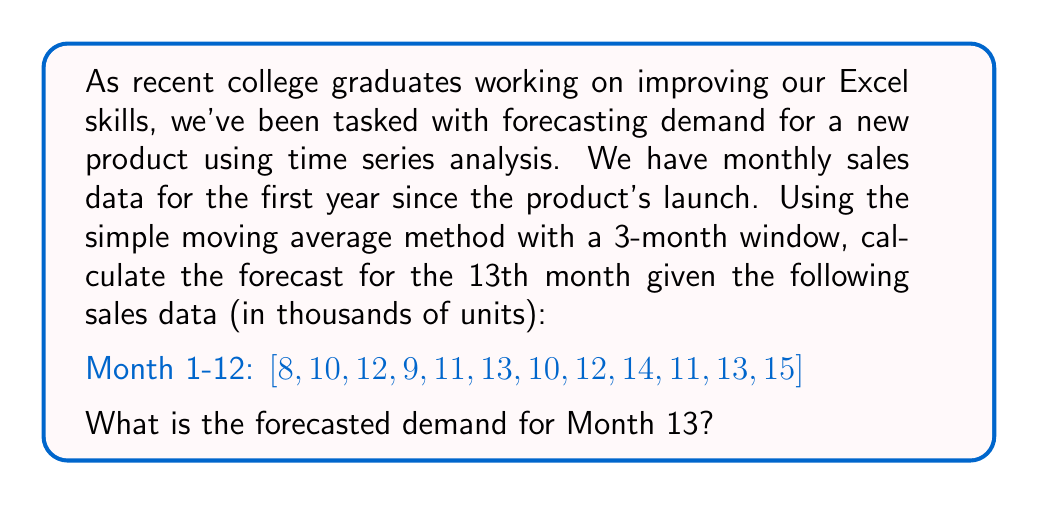Provide a solution to this math problem. Let's approach this step-by-step:

1) The simple moving average method uses the average of a fixed number of past periods to forecast the next period. In this case, we're using a 3-month window.

2) To forecast Month 13, we'll use the sales data from Months 10, 11, and 12.

3) The formula for a 3-month simple moving average is:

   $$F_{t+1} = \frac{D_t + D_{t-1} + D_{t-2}}{3}$$

   Where:
   $F_{t+1}$ is the forecast for the next period
   $D_t$, $D_{t-1}$, and $D_{t-2}$ are the demand values for the current period and the two preceding periods

4) From our data:
   Month 10: 11 thousand units
   Month 11: 13 thousand units
   Month 12: 15 thousand units

5) Plugging these values into our formula:

   $$F_{13} = \frac{15 + 13 + 11}{3} = \frac{39}{3} = 13$$

Therefore, the forecasted demand for Month 13 is 13 thousand units.

This method assumes that the most recent data points are the best predictors of future demand, which is often a reasonable assumption for short-term forecasting.
Answer: The forecasted demand for Month 13 is 13 thousand units. 